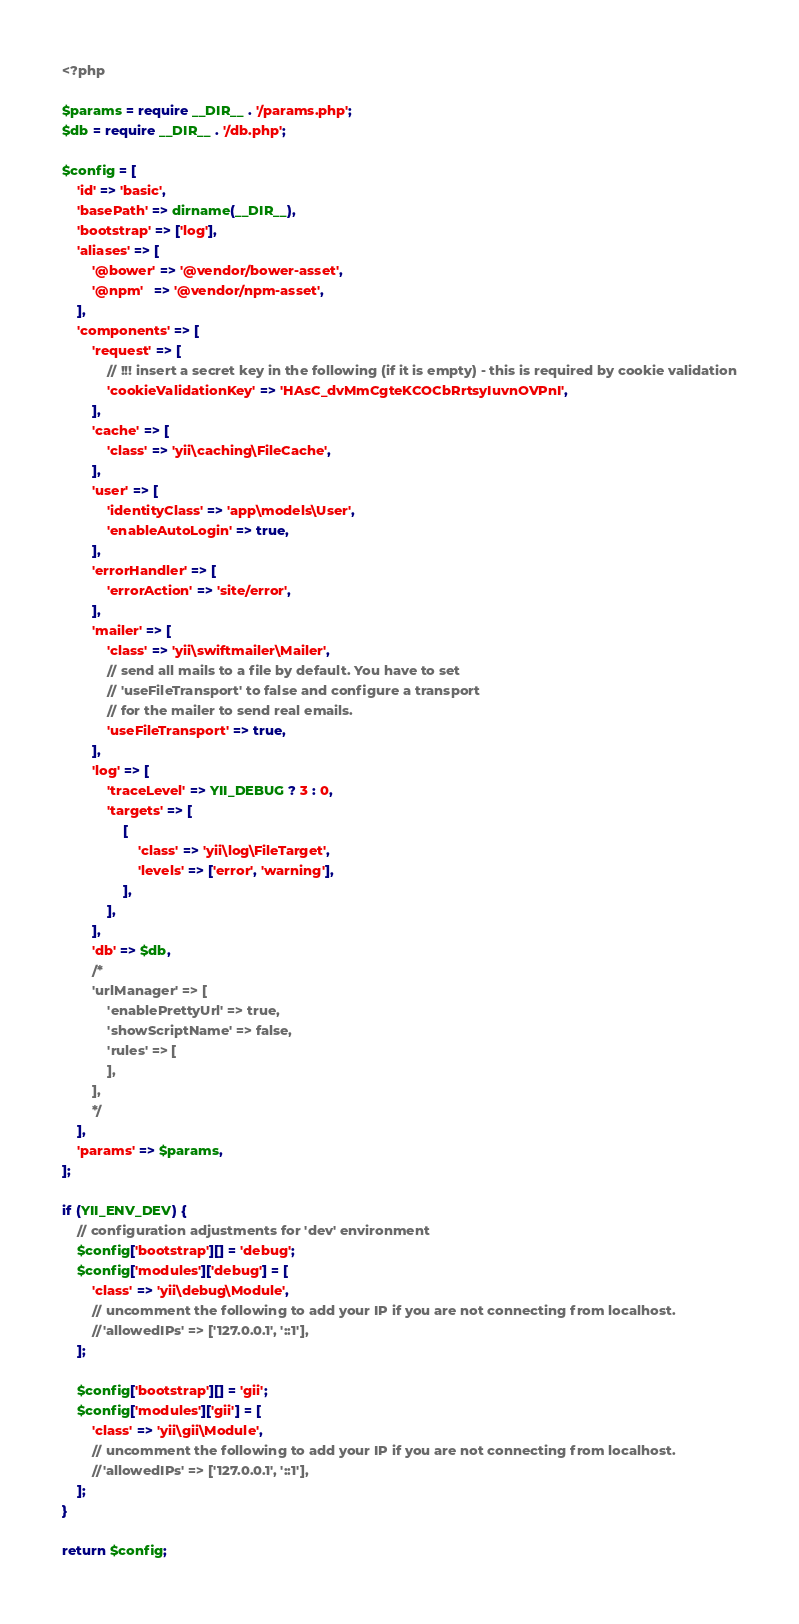Convert code to text. <code><loc_0><loc_0><loc_500><loc_500><_PHP_><?php

$params = require __DIR__ . '/params.php';
$db = require __DIR__ . '/db.php';

$config = [
    'id' => 'basic',
    'basePath' => dirname(__DIR__),
    'bootstrap' => ['log'],
    'aliases' => [
        '@bower' => '@vendor/bower-asset',
        '@npm'   => '@vendor/npm-asset',
    ],
    'components' => [
        'request' => [
            // !!! insert a secret key in the following (if it is empty) - this is required by cookie validation
            'cookieValidationKey' => 'HAsC_dvMmCgteKCOCbRrtsyIuvnOVPnI',
        ],
        'cache' => [
            'class' => 'yii\caching\FileCache',
        ],
        'user' => [
            'identityClass' => 'app\models\User',
            'enableAutoLogin' => true,
        ],
        'errorHandler' => [
            'errorAction' => 'site/error',
        ],
        'mailer' => [
            'class' => 'yii\swiftmailer\Mailer',
            // send all mails to a file by default. You have to set
            // 'useFileTransport' to false and configure a transport
            // for the mailer to send real emails.
            'useFileTransport' => true,
        ],
        'log' => [
            'traceLevel' => YII_DEBUG ? 3 : 0,
            'targets' => [
                [
                    'class' => 'yii\log\FileTarget',
                    'levels' => ['error', 'warning'],
                ],
            ],
        ],
        'db' => $db,
        /*
        'urlManager' => [
            'enablePrettyUrl' => true,
            'showScriptName' => false,
            'rules' => [
            ],
        ],
        */
    ],
    'params' => $params,
];

if (YII_ENV_DEV) {
    // configuration adjustments for 'dev' environment
    $config['bootstrap'][] = 'debug';
    $config['modules']['debug'] = [
        'class' => 'yii\debug\Module',
        // uncomment the following to add your IP if you are not connecting from localhost.
        //'allowedIPs' => ['127.0.0.1', '::1'],
    ];

    $config['bootstrap'][] = 'gii';
    $config['modules']['gii'] = [
        'class' => 'yii\gii\Module',
        // uncomment the following to add your IP if you are not connecting from localhost.
        //'allowedIPs' => ['127.0.0.1', '::1'],
    ];
}

return $config;
</code> 